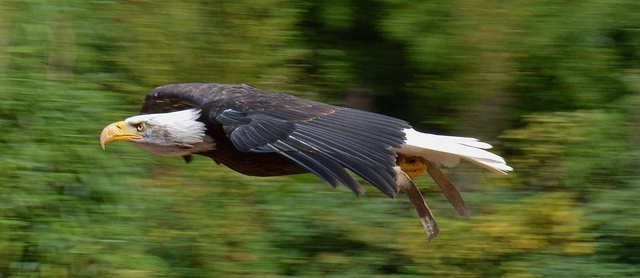Describe the objects in this image and their specific colors. I can see a bird in olive, black, gray, and white tones in this image. 